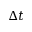Convert formula to latex. <formula><loc_0><loc_0><loc_500><loc_500>\Delta t</formula> 